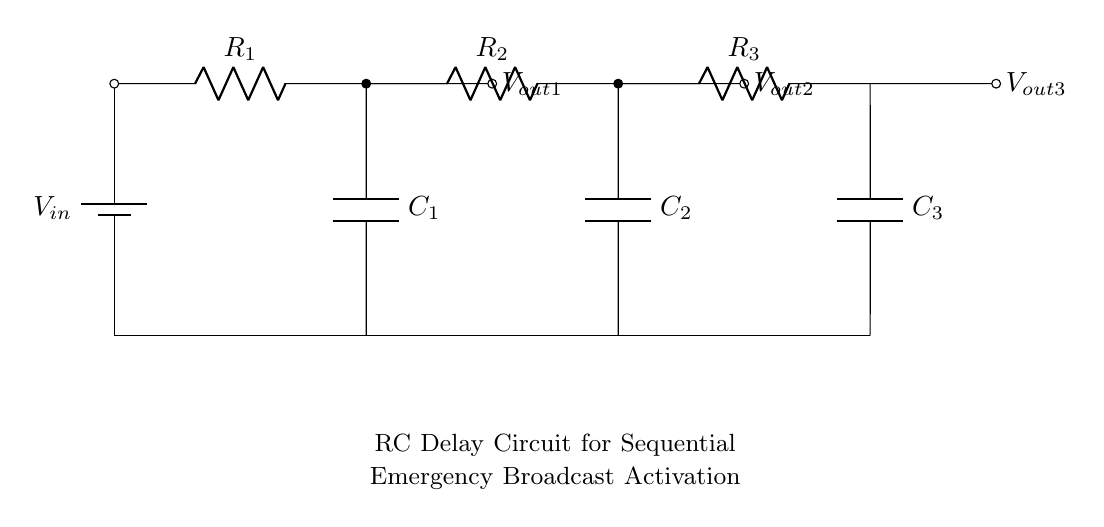What components are present in the circuit? The components are resistors and capacitors, specifically three resistors and three capacitors. This is determined by visually identifying their symbols and labels in the diagram.
Answer: resistors and capacitors What is the function of capacitor C1? Capacitor C1 is part of the timing circuit that introduces a delay in the voltage output by charging and discharging. This is inferred from its position in the circuit, where it is connected to a resistor and outputs a signal.
Answer: timing delay How many output voltages are indicated? There are three output voltages indicated as Vout1, Vout2, and Vout3, which are shown as connections following each of the resistors in the circuit.
Answer: three What is the direct relationship between resistors and output voltage in this circuit? The output voltage is affected by the combined resistance and capacitance, with a higher resistance typically leading to a longer charging time for the capacitor, causing a delayed output. This is based on the RC time constant principle, which governs the behavior of RC circuits.
Answer: higher resistance leads to delayed output What is the overall purpose of this RC delay circuit? The overall purpose is to control the sequential activation of emergency broadcast systems, allowing multiple outputs over time. This is deduced from the naming indication beneath the diagram and the arrangement of resistors and capacitors that create delays.
Answer: sequential activation of emergency broadcasts 